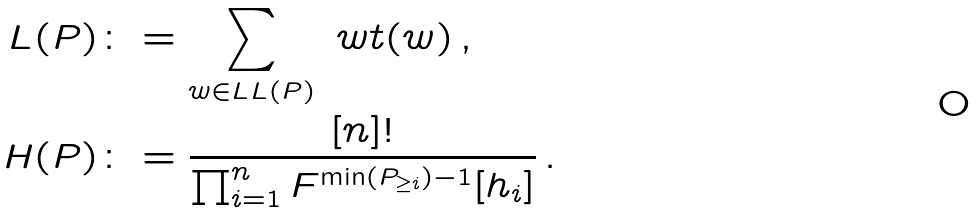<formula> <loc_0><loc_0><loc_500><loc_500>L ( P ) & \colon = \sum _ { w \in \L L L ( P ) } \ w t ( w ) \, , \\ H ( P ) & \colon = \frac { [ n ] ! } { \prod _ { i = 1 } ^ { n } F ^ { \min ( P _ { \geq i } ) - 1 } [ h _ { i } ] } \, .</formula> 